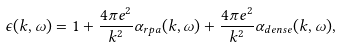Convert formula to latex. <formula><loc_0><loc_0><loc_500><loc_500>\epsilon ( k , \omega ) = 1 + \frac { 4 \pi e ^ { 2 } } { k ^ { 2 } } \alpha _ { r p a } ( k , \omega ) + \frac { 4 \pi e ^ { 2 } } { k ^ { 2 } } \alpha _ { d e n s e } ( k , \omega ) ,</formula> 